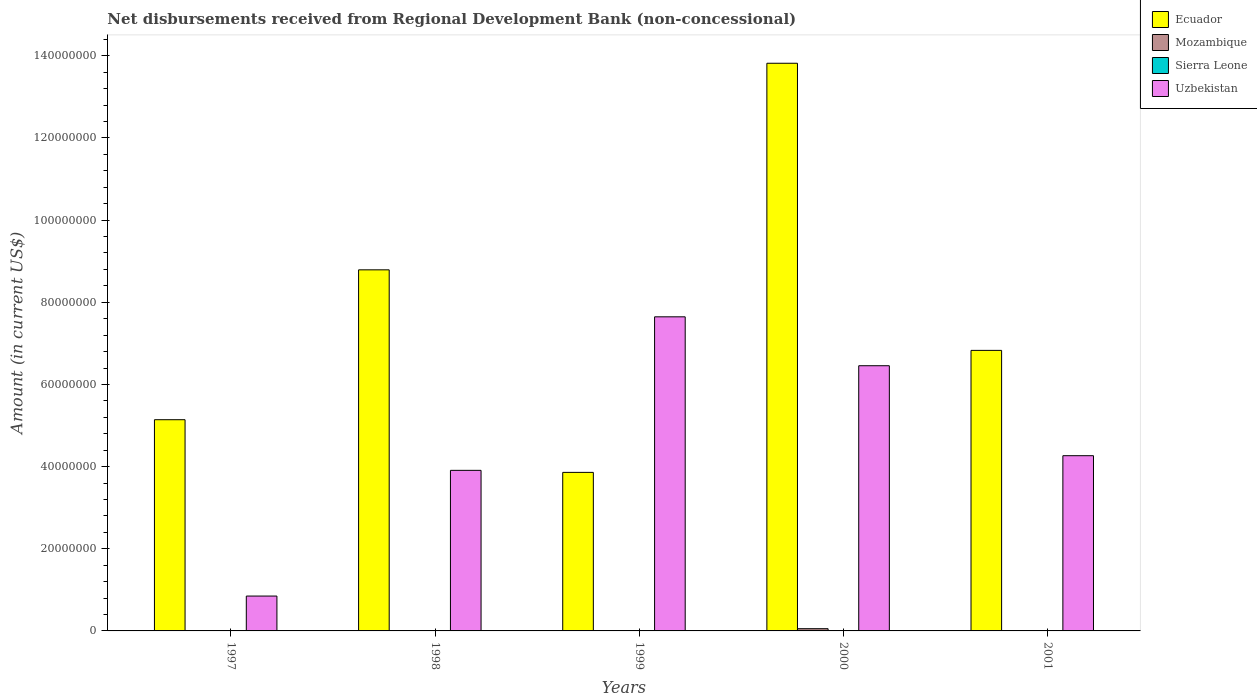How many different coloured bars are there?
Make the answer very short. 4. How many groups of bars are there?
Give a very brief answer. 5. Are the number of bars per tick equal to the number of legend labels?
Your response must be concise. No. How many bars are there on the 3rd tick from the left?
Keep it short and to the point. 3. How many bars are there on the 2nd tick from the right?
Your answer should be compact. 4. What is the amount of disbursements received from Regional Development Bank in Sierra Leone in 1999?
Ensure brevity in your answer.  3.10e+04. Across all years, what is the maximum amount of disbursements received from Regional Development Bank in Sierra Leone?
Make the answer very short. 4.50e+04. Across all years, what is the minimum amount of disbursements received from Regional Development Bank in Uzbekistan?
Your response must be concise. 8.49e+06. What is the total amount of disbursements received from Regional Development Bank in Uzbekistan in the graph?
Your answer should be very brief. 2.31e+08. What is the difference between the amount of disbursements received from Regional Development Bank in Sierra Leone in 1998 and that in 1999?
Your response must be concise. 8000. What is the difference between the amount of disbursements received from Regional Development Bank in Uzbekistan in 2000 and the amount of disbursements received from Regional Development Bank in Sierra Leone in 1999?
Provide a succinct answer. 6.45e+07. What is the average amount of disbursements received from Regional Development Bank in Ecuador per year?
Make the answer very short. 7.69e+07. In the year 1997, what is the difference between the amount of disbursements received from Regional Development Bank in Sierra Leone and amount of disbursements received from Regional Development Bank in Uzbekistan?
Make the answer very short. -8.44e+06. In how many years, is the amount of disbursements received from Regional Development Bank in Ecuador greater than 132000000 US$?
Your answer should be very brief. 1. What is the ratio of the amount of disbursements received from Regional Development Bank in Sierra Leone in 1999 to that in 2000?
Your answer should be compact. 1.48. Is the difference between the amount of disbursements received from Regional Development Bank in Sierra Leone in 1997 and 2000 greater than the difference between the amount of disbursements received from Regional Development Bank in Uzbekistan in 1997 and 2000?
Your answer should be very brief. Yes. What is the difference between the highest and the second highest amount of disbursements received from Regional Development Bank in Uzbekistan?
Give a very brief answer. 1.19e+07. What is the difference between the highest and the lowest amount of disbursements received from Regional Development Bank in Uzbekistan?
Offer a very short reply. 6.80e+07. In how many years, is the amount of disbursements received from Regional Development Bank in Sierra Leone greater than the average amount of disbursements received from Regional Development Bank in Sierra Leone taken over all years?
Give a very brief answer. 3. How many years are there in the graph?
Your answer should be very brief. 5. What is the difference between two consecutive major ticks on the Y-axis?
Keep it short and to the point. 2.00e+07. Does the graph contain any zero values?
Keep it short and to the point. Yes. Does the graph contain grids?
Your answer should be very brief. No. How many legend labels are there?
Offer a terse response. 4. What is the title of the graph?
Make the answer very short. Net disbursements received from Regional Development Bank (non-concessional). Does "Congo (Republic)" appear as one of the legend labels in the graph?
Keep it short and to the point. No. What is the label or title of the X-axis?
Offer a very short reply. Years. What is the Amount (in current US$) of Ecuador in 1997?
Ensure brevity in your answer.  5.14e+07. What is the Amount (in current US$) of Mozambique in 1997?
Provide a short and direct response. 0. What is the Amount (in current US$) in Sierra Leone in 1997?
Your response must be concise. 4.50e+04. What is the Amount (in current US$) in Uzbekistan in 1997?
Ensure brevity in your answer.  8.49e+06. What is the Amount (in current US$) in Ecuador in 1998?
Offer a terse response. 8.79e+07. What is the Amount (in current US$) of Sierra Leone in 1998?
Offer a terse response. 3.90e+04. What is the Amount (in current US$) of Uzbekistan in 1998?
Keep it short and to the point. 3.91e+07. What is the Amount (in current US$) of Ecuador in 1999?
Ensure brevity in your answer.  3.86e+07. What is the Amount (in current US$) of Mozambique in 1999?
Provide a succinct answer. 0. What is the Amount (in current US$) of Sierra Leone in 1999?
Ensure brevity in your answer.  3.10e+04. What is the Amount (in current US$) of Uzbekistan in 1999?
Offer a terse response. 7.65e+07. What is the Amount (in current US$) of Ecuador in 2000?
Make the answer very short. 1.38e+08. What is the Amount (in current US$) in Mozambique in 2000?
Provide a succinct answer. 5.43e+05. What is the Amount (in current US$) of Sierra Leone in 2000?
Offer a terse response. 2.10e+04. What is the Amount (in current US$) of Uzbekistan in 2000?
Provide a short and direct response. 6.46e+07. What is the Amount (in current US$) of Ecuador in 2001?
Give a very brief answer. 6.83e+07. What is the Amount (in current US$) in Mozambique in 2001?
Give a very brief answer. 0. What is the Amount (in current US$) in Sierra Leone in 2001?
Provide a succinct answer. 0. What is the Amount (in current US$) in Uzbekistan in 2001?
Offer a terse response. 4.27e+07. Across all years, what is the maximum Amount (in current US$) of Ecuador?
Provide a short and direct response. 1.38e+08. Across all years, what is the maximum Amount (in current US$) in Mozambique?
Provide a short and direct response. 5.43e+05. Across all years, what is the maximum Amount (in current US$) of Sierra Leone?
Give a very brief answer. 4.50e+04. Across all years, what is the maximum Amount (in current US$) of Uzbekistan?
Ensure brevity in your answer.  7.65e+07. Across all years, what is the minimum Amount (in current US$) in Ecuador?
Provide a succinct answer. 3.86e+07. Across all years, what is the minimum Amount (in current US$) of Sierra Leone?
Offer a very short reply. 0. Across all years, what is the minimum Amount (in current US$) in Uzbekistan?
Your response must be concise. 8.49e+06. What is the total Amount (in current US$) of Ecuador in the graph?
Provide a short and direct response. 3.84e+08. What is the total Amount (in current US$) in Mozambique in the graph?
Make the answer very short. 5.43e+05. What is the total Amount (in current US$) in Sierra Leone in the graph?
Provide a succinct answer. 1.36e+05. What is the total Amount (in current US$) of Uzbekistan in the graph?
Give a very brief answer. 2.31e+08. What is the difference between the Amount (in current US$) of Ecuador in 1997 and that in 1998?
Offer a terse response. -3.65e+07. What is the difference between the Amount (in current US$) in Sierra Leone in 1997 and that in 1998?
Ensure brevity in your answer.  6000. What is the difference between the Amount (in current US$) in Uzbekistan in 1997 and that in 1998?
Provide a succinct answer. -3.06e+07. What is the difference between the Amount (in current US$) in Ecuador in 1997 and that in 1999?
Give a very brief answer. 1.28e+07. What is the difference between the Amount (in current US$) in Sierra Leone in 1997 and that in 1999?
Provide a succinct answer. 1.40e+04. What is the difference between the Amount (in current US$) in Uzbekistan in 1997 and that in 1999?
Offer a terse response. -6.80e+07. What is the difference between the Amount (in current US$) in Ecuador in 1997 and that in 2000?
Ensure brevity in your answer.  -8.68e+07. What is the difference between the Amount (in current US$) of Sierra Leone in 1997 and that in 2000?
Your answer should be very brief. 2.40e+04. What is the difference between the Amount (in current US$) of Uzbekistan in 1997 and that in 2000?
Offer a terse response. -5.61e+07. What is the difference between the Amount (in current US$) in Ecuador in 1997 and that in 2001?
Ensure brevity in your answer.  -1.69e+07. What is the difference between the Amount (in current US$) in Uzbekistan in 1997 and that in 2001?
Offer a terse response. -3.42e+07. What is the difference between the Amount (in current US$) of Ecuador in 1998 and that in 1999?
Your response must be concise. 4.93e+07. What is the difference between the Amount (in current US$) in Sierra Leone in 1998 and that in 1999?
Provide a succinct answer. 8000. What is the difference between the Amount (in current US$) of Uzbekistan in 1998 and that in 1999?
Offer a very short reply. -3.74e+07. What is the difference between the Amount (in current US$) in Ecuador in 1998 and that in 2000?
Ensure brevity in your answer.  -5.03e+07. What is the difference between the Amount (in current US$) in Sierra Leone in 1998 and that in 2000?
Ensure brevity in your answer.  1.80e+04. What is the difference between the Amount (in current US$) in Uzbekistan in 1998 and that in 2000?
Provide a succinct answer. -2.55e+07. What is the difference between the Amount (in current US$) in Ecuador in 1998 and that in 2001?
Your answer should be compact. 1.96e+07. What is the difference between the Amount (in current US$) of Uzbekistan in 1998 and that in 2001?
Your answer should be very brief. -3.57e+06. What is the difference between the Amount (in current US$) of Ecuador in 1999 and that in 2000?
Offer a very short reply. -9.96e+07. What is the difference between the Amount (in current US$) in Sierra Leone in 1999 and that in 2000?
Offer a terse response. 10000. What is the difference between the Amount (in current US$) in Uzbekistan in 1999 and that in 2000?
Make the answer very short. 1.19e+07. What is the difference between the Amount (in current US$) in Ecuador in 1999 and that in 2001?
Provide a succinct answer. -2.97e+07. What is the difference between the Amount (in current US$) of Uzbekistan in 1999 and that in 2001?
Provide a short and direct response. 3.38e+07. What is the difference between the Amount (in current US$) in Ecuador in 2000 and that in 2001?
Provide a short and direct response. 6.99e+07. What is the difference between the Amount (in current US$) in Uzbekistan in 2000 and that in 2001?
Your response must be concise. 2.19e+07. What is the difference between the Amount (in current US$) in Ecuador in 1997 and the Amount (in current US$) in Sierra Leone in 1998?
Ensure brevity in your answer.  5.14e+07. What is the difference between the Amount (in current US$) of Ecuador in 1997 and the Amount (in current US$) of Uzbekistan in 1998?
Your answer should be compact. 1.23e+07. What is the difference between the Amount (in current US$) in Sierra Leone in 1997 and the Amount (in current US$) in Uzbekistan in 1998?
Your answer should be very brief. -3.90e+07. What is the difference between the Amount (in current US$) of Ecuador in 1997 and the Amount (in current US$) of Sierra Leone in 1999?
Your response must be concise. 5.14e+07. What is the difference between the Amount (in current US$) of Ecuador in 1997 and the Amount (in current US$) of Uzbekistan in 1999?
Keep it short and to the point. -2.50e+07. What is the difference between the Amount (in current US$) of Sierra Leone in 1997 and the Amount (in current US$) of Uzbekistan in 1999?
Give a very brief answer. -7.64e+07. What is the difference between the Amount (in current US$) in Ecuador in 1997 and the Amount (in current US$) in Mozambique in 2000?
Provide a succinct answer. 5.09e+07. What is the difference between the Amount (in current US$) of Ecuador in 1997 and the Amount (in current US$) of Sierra Leone in 2000?
Keep it short and to the point. 5.14e+07. What is the difference between the Amount (in current US$) of Ecuador in 1997 and the Amount (in current US$) of Uzbekistan in 2000?
Give a very brief answer. -1.31e+07. What is the difference between the Amount (in current US$) of Sierra Leone in 1997 and the Amount (in current US$) of Uzbekistan in 2000?
Ensure brevity in your answer.  -6.45e+07. What is the difference between the Amount (in current US$) of Ecuador in 1997 and the Amount (in current US$) of Uzbekistan in 2001?
Give a very brief answer. 8.76e+06. What is the difference between the Amount (in current US$) in Sierra Leone in 1997 and the Amount (in current US$) in Uzbekistan in 2001?
Offer a terse response. -4.26e+07. What is the difference between the Amount (in current US$) in Ecuador in 1998 and the Amount (in current US$) in Sierra Leone in 1999?
Your answer should be very brief. 8.79e+07. What is the difference between the Amount (in current US$) in Ecuador in 1998 and the Amount (in current US$) in Uzbekistan in 1999?
Provide a succinct answer. 1.14e+07. What is the difference between the Amount (in current US$) in Sierra Leone in 1998 and the Amount (in current US$) in Uzbekistan in 1999?
Offer a very short reply. -7.64e+07. What is the difference between the Amount (in current US$) of Ecuador in 1998 and the Amount (in current US$) of Mozambique in 2000?
Give a very brief answer. 8.74e+07. What is the difference between the Amount (in current US$) of Ecuador in 1998 and the Amount (in current US$) of Sierra Leone in 2000?
Offer a terse response. 8.79e+07. What is the difference between the Amount (in current US$) in Ecuador in 1998 and the Amount (in current US$) in Uzbekistan in 2000?
Provide a short and direct response. 2.33e+07. What is the difference between the Amount (in current US$) in Sierra Leone in 1998 and the Amount (in current US$) in Uzbekistan in 2000?
Provide a succinct answer. -6.45e+07. What is the difference between the Amount (in current US$) in Ecuador in 1998 and the Amount (in current US$) in Uzbekistan in 2001?
Provide a short and direct response. 4.52e+07. What is the difference between the Amount (in current US$) in Sierra Leone in 1998 and the Amount (in current US$) in Uzbekistan in 2001?
Provide a short and direct response. -4.26e+07. What is the difference between the Amount (in current US$) of Ecuador in 1999 and the Amount (in current US$) of Mozambique in 2000?
Provide a short and direct response. 3.80e+07. What is the difference between the Amount (in current US$) of Ecuador in 1999 and the Amount (in current US$) of Sierra Leone in 2000?
Provide a succinct answer. 3.86e+07. What is the difference between the Amount (in current US$) of Ecuador in 1999 and the Amount (in current US$) of Uzbekistan in 2000?
Offer a terse response. -2.60e+07. What is the difference between the Amount (in current US$) of Sierra Leone in 1999 and the Amount (in current US$) of Uzbekistan in 2000?
Make the answer very short. -6.45e+07. What is the difference between the Amount (in current US$) in Ecuador in 1999 and the Amount (in current US$) in Uzbekistan in 2001?
Provide a succinct answer. -4.06e+06. What is the difference between the Amount (in current US$) of Sierra Leone in 1999 and the Amount (in current US$) of Uzbekistan in 2001?
Offer a terse response. -4.26e+07. What is the difference between the Amount (in current US$) of Ecuador in 2000 and the Amount (in current US$) of Uzbekistan in 2001?
Make the answer very short. 9.55e+07. What is the difference between the Amount (in current US$) in Mozambique in 2000 and the Amount (in current US$) in Uzbekistan in 2001?
Offer a terse response. -4.21e+07. What is the difference between the Amount (in current US$) in Sierra Leone in 2000 and the Amount (in current US$) in Uzbekistan in 2001?
Make the answer very short. -4.26e+07. What is the average Amount (in current US$) of Ecuador per year?
Make the answer very short. 7.69e+07. What is the average Amount (in current US$) of Mozambique per year?
Offer a very short reply. 1.09e+05. What is the average Amount (in current US$) of Sierra Leone per year?
Keep it short and to the point. 2.72e+04. What is the average Amount (in current US$) of Uzbekistan per year?
Provide a succinct answer. 4.62e+07. In the year 1997, what is the difference between the Amount (in current US$) in Ecuador and Amount (in current US$) in Sierra Leone?
Your response must be concise. 5.14e+07. In the year 1997, what is the difference between the Amount (in current US$) in Ecuador and Amount (in current US$) in Uzbekistan?
Keep it short and to the point. 4.29e+07. In the year 1997, what is the difference between the Amount (in current US$) in Sierra Leone and Amount (in current US$) in Uzbekistan?
Give a very brief answer. -8.44e+06. In the year 1998, what is the difference between the Amount (in current US$) of Ecuador and Amount (in current US$) of Sierra Leone?
Provide a succinct answer. 8.79e+07. In the year 1998, what is the difference between the Amount (in current US$) in Ecuador and Amount (in current US$) in Uzbekistan?
Your answer should be very brief. 4.88e+07. In the year 1998, what is the difference between the Amount (in current US$) in Sierra Leone and Amount (in current US$) in Uzbekistan?
Offer a very short reply. -3.90e+07. In the year 1999, what is the difference between the Amount (in current US$) of Ecuador and Amount (in current US$) of Sierra Leone?
Give a very brief answer. 3.86e+07. In the year 1999, what is the difference between the Amount (in current US$) of Ecuador and Amount (in current US$) of Uzbekistan?
Ensure brevity in your answer.  -3.79e+07. In the year 1999, what is the difference between the Amount (in current US$) in Sierra Leone and Amount (in current US$) in Uzbekistan?
Your answer should be compact. -7.64e+07. In the year 2000, what is the difference between the Amount (in current US$) of Ecuador and Amount (in current US$) of Mozambique?
Your answer should be very brief. 1.38e+08. In the year 2000, what is the difference between the Amount (in current US$) of Ecuador and Amount (in current US$) of Sierra Leone?
Ensure brevity in your answer.  1.38e+08. In the year 2000, what is the difference between the Amount (in current US$) in Ecuador and Amount (in current US$) in Uzbekistan?
Ensure brevity in your answer.  7.36e+07. In the year 2000, what is the difference between the Amount (in current US$) of Mozambique and Amount (in current US$) of Sierra Leone?
Provide a short and direct response. 5.22e+05. In the year 2000, what is the difference between the Amount (in current US$) in Mozambique and Amount (in current US$) in Uzbekistan?
Offer a very short reply. -6.40e+07. In the year 2000, what is the difference between the Amount (in current US$) in Sierra Leone and Amount (in current US$) in Uzbekistan?
Give a very brief answer. -6.45e+07. In the year 2001, what is the difference between the Amount (in current US$) in Ecuador and Amount (in current US$) in Uzbekistan?
Ensure brevity in your answer.  2.56e+07. What is the ratio of the Amount (in current US$) of Ecuador in 1997 to that in 1998?
Your answer should be compact. 0.58. What is the ratio of the Amount (in current US$) of Sierra Leone in 1997 to that in 1998?
Your response must be concise. 1.15. What is the ratio of the Amount (in current US$) of Uzbekistan in 1997 to that in 1998?
Offer a terse response. 0.22. What is the ratio of the Amount (in current US$) of Ecuador in 1997 to that in 1999?
Offer a terse response. 1.33. What is the ratio of the Amount (in current US$) of Sierra Leone in 1997 to that in 1999?
Your response must be concise. 1.45. What is the ratio of the Amount (in current US$) of Uzbekistan in 1997 to that in 1999?
Offer a terse response. 0.11. What is the ratio of the Amount (in current US$) in Ecuador in 1997 to that in 2000?
Provide a succinct answer. 0.37. What is the ratio of the Amount (in current US$) of Sierra Leone in 1997 to that in 2000?
Provide a short and direct response. 2.14. What is the ratio of the Amount (in current US$) in Uzbekistan in 1997 to that in 2000?
Provide a short and direct response. 0.13. What is the ratio of the Amount (in current US$) in Ecuador in 1997 to that in 2001?
Your response must be concise. 0.75. What is the ratio of the Amount (in current US$) of Uzbekistan in 1997 to that in 2001?
Give a very brief answer. 0.2. What is the ratio of the Amount (in current US$) in Ecuador in 1998 to that in 1999?
Your answer should be very brief. 2.28. What is the ratio of the Amount (in current US$) of Sierra Leone in 1998 to that in 1999?
Keep it short and to the point. 1.26. What is the ratio of the Amount (in current US$) in Uzbekistan in 1998 to that in 1999?
Your response must be concise. 0.51. What is the ratio of the Amount (in current US$) of Ecuador in 1998 to that in 2000?
Your response must be concise. 0.64. What is the ratio of the Amount (in current US$) of Sierra Leone in 1998 to that in 2000?
Ensure brevity in your answer.  1.86. What is the ratio of the Amount (in current US$) in Uzbekistan in 1998 to that in 2000?
Your answer should be compact. 0.61. What is the ratio of the Amount (in current US$) in Ecuador in 1998 to that in 2001?
Ensure brevity in your answer.  1.29. What is the ratio of the Amount (in current US$) in Uzbekistan in 1998 to that in 2001?
Ensure brevity in your answer.  0.92. What is the ratio of the Amount (in current US$) in Ecuador in 1999 to that in 2000?
Offer a very short reply. 0.28. What is the ratio of the Amount (in current US$) in Sierra Leone in 1999 to that in 2000?
Provide a short and direct response. 1.48. What is the ratio of the Amount (in current US$) in Uzbekistan in 1999 to that in 2000?
Offer a very short reply. 1.18. What is the ratio of the Amount (in current US$) of Ecuador in 1999 to that in 2001?
Ensure brevity in your answer.  0.57. What is the ratio of the Amount (in current US$) of Uzbekistan in 1999 to that in 2001?
Provide a short and direct response. 1.79. What is the ratio of the Amount (in current US$) of Ecuador in 2000 to that in 2001?
Offer a very short reply. 2.02. What is the ratio of the Amount (in current US$) of Uzbekistan in 2000 to that in 2001?
Provide a short and direct response. 1.51. What is the difference between the highest and the second highest Amount (in current US$) of Ecuador?
Keep it short and to the point. 5.03e+07. What is the difference between the highest and the second highest Amount (in current US$) of Sierra Leone?
Offer a very short reply. 6000. What is the difference between the highest and the second highest Amount (in current US$) of Uzbekistan?
Your response must be concise. 1.19e+07. What is the difference between the highest and the lowest Amount (in current US$) in Ecuador?
Give a very brief answer. 9.96e+07. What is the difference between the highest and the lowest Amount (in current US$) in Mozambique?
Provide a short and direct response. 5.43e+05. What is the difference between the highest and the lowest Amount (in current US$) in Sierra Leone?
Provide a short and direct response. 4.50e+04. What is the difference between the highest and the lowest Amount (in current US$) in Uzbekistan?
Make the answer very short. 6.80e+07. 